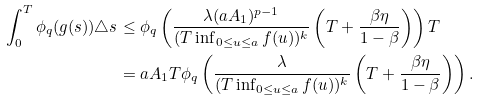Convert formula to latex. <formula><loc_0><loc_0><loc_500><loc_500>\int _ { 0 } ^ { T } \phi _ { q } ( g ( s ) ) \triangle s & \leq \phi _ { q } \left ( \frac { \lambda ( a A _ { 1 } ) ^ { p - 1 } } { ( T \inf _ { 0 \leq u \leq a } f ( u ) ) ^ { k } } \left ( T + \frac { \beta \eta } { 1 - \beta } \right ) \right ) T \\ & = a A _ { 1 } T \phi _ { q } \left ( \frac { \lambda } { ( T \inf _ { 0 \leq u \leq a } f ( u ) ) ^ { k } } \left ( T + \frac { \beta \eta } { 1 - \beta } \right ) \right ) .</formula> 